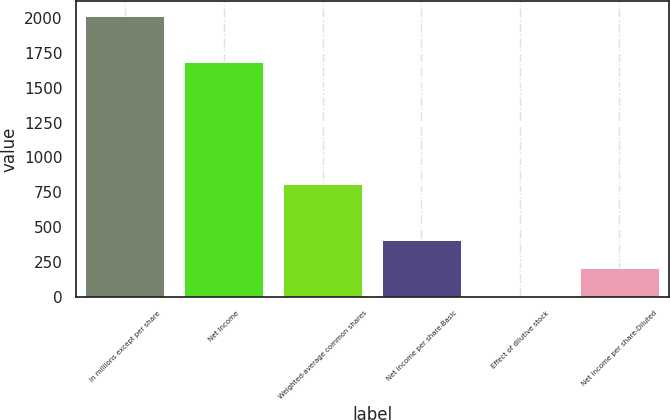<chart> <loc_0><loc_0><loc_500><loc_500><bar_chart><fcel>In millions except per share<fcel>Net Income<fcel>Weighted-average common shares<fcel>Net income per share-Basic<fcel>Effect of dilutive stock<fcel>Net income per share-Diluted<nl><fcel>2017<fcel>1687<fcel>808.42<fcel>405.56<fcel>2.7<fcel>204.13<nl></chart> 